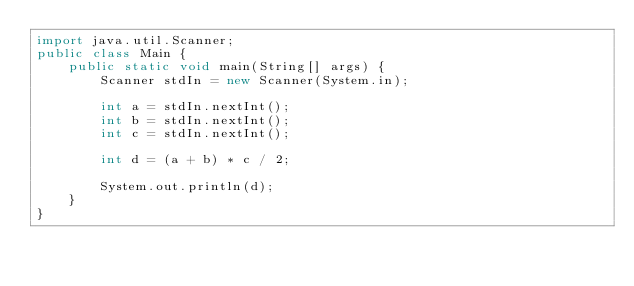Convert code to text. <code><loc_0><loc_0><loc_500><loc_500><_Java_>import java.util.Scanner;
public class Main {
	public static void main(String[] args) {
		Scanner stdIn = new Scanner(System.in);
		
		int a = stdIn.nextInt();
		int b = stdIn.nextInt();
		int c = stdIn.nextInt();
		
		int d = (a + b) * c / 2;
		
		System.out.println(d);
	}
}</code> 